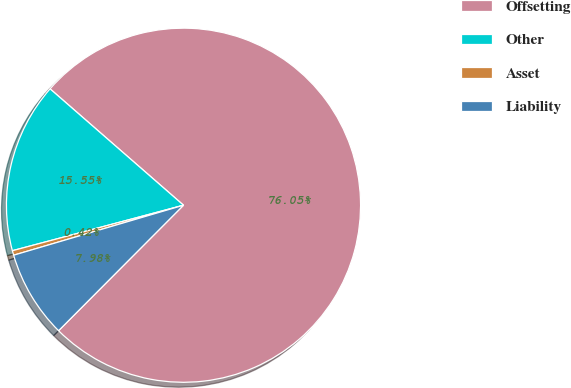Convert chart. <chart><loc_0><loc_0><loc_500><loc_500><pie_chart><fcel>Offsetting<fcel>Other<fcel>Asset<fcel>Liability<nl><fcel>76.05%<fcel>15.55%<fcel>0.42%<fcel>7.98%<nl></chart> 